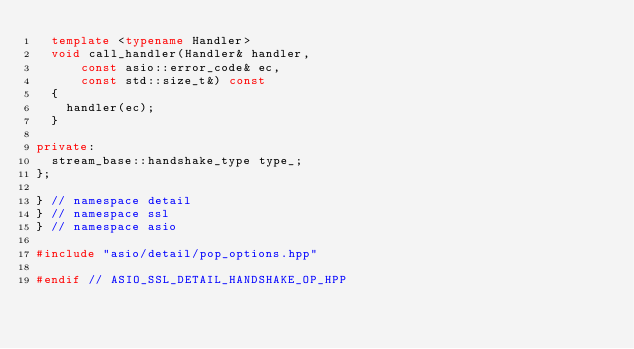<code> <loc_0><loc_0><loc_500><loc_500><_C++_>  template <typename Handler>
  void call_handler(Handler& handler,
      const asio::error_code& ec,
      const std::size_t&) const
  {
    handler(ec);
  }

private:
  stream_base::handshake_type type_;
};

} // namespace detail
} // namespace ssl
} // namespace asio

#include "asio/detail/pop_options.hpp"

#endif // ASIO_SSL_DETAIL_HANDSHAKE_OP_HPP
</code> 